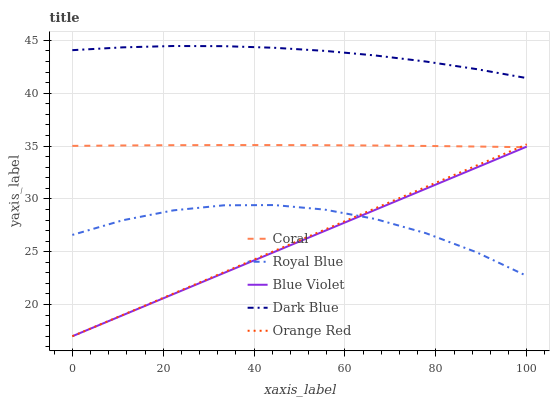Does Blue Violet have the minimum area under the curve?
Answer yes or no. Yes. Does Dark Blue have the maximum area under the curve?
Answer yes or no. Yes. Does Coral have the minimum area under the curve?
Answer yes or no. No. Does Coral have the maximum area under the curve?
Answer yes or no. No. Is Blue Violet the smoothest?
Answer yes or no. Yes. Is Royal Blue the roughest?
Answer yes or no. Yes. Is Coral the smoothest?
Answer yes or no. No. Is Coral the roughest?
Answer yes or no. No. Does Coral have the lowest value?
Answer yes or no. No. Does Dark Blue have the highest value?
Answer yes or no. Yes. Does Coral have the highest value?
Answer yes or no. No. Is Coral less than Dark Blue?
Answer yes or no. Yes. Is Dark Blue greater than Royal Blue?
Answer yes or no. Yes. Does Coral intersect Orange Red?
Answer yes or no. Yes. Is Coral less than Orange Red?
Answer yes or no. No. Is Coral greater than Orange Red?
Answer yes or no. No. Does Coral intersect Dark Blue?
Answer yes or no. No. 